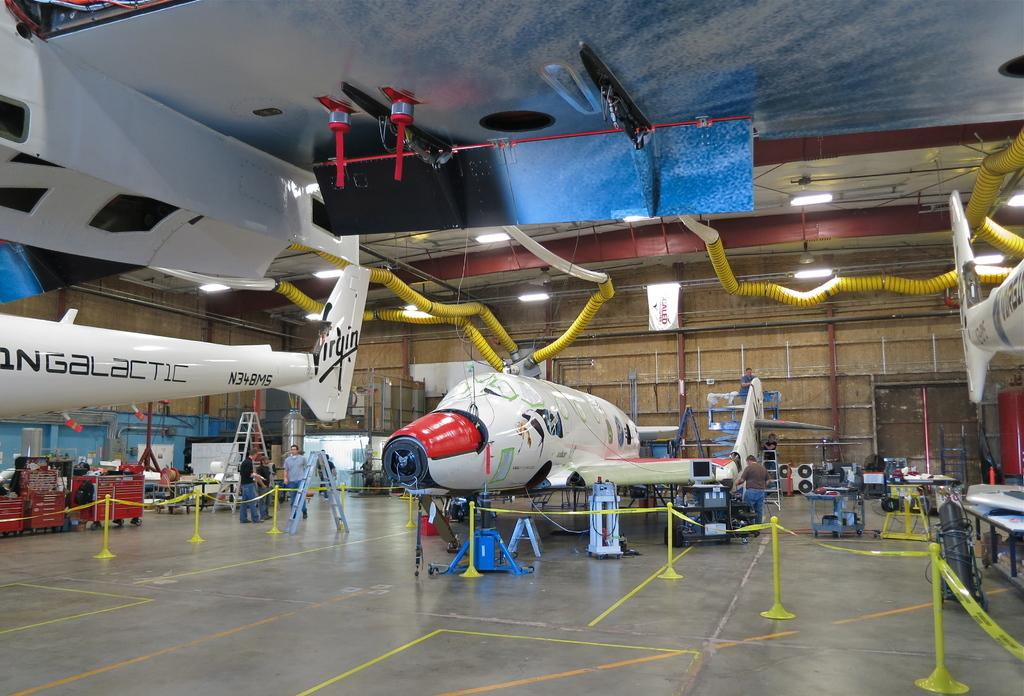<image>
Describe the image concisely. Virgin airlines airplanes being assembled in a factory 